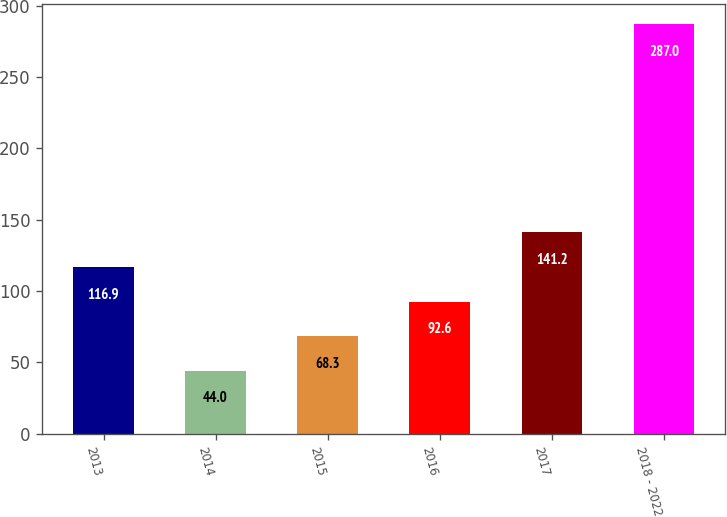<chart> <loc_0><loc_0><loc_500><loc_500><bar_chart><fcel>2013<fcel>2014<fcel>2015<fcel>2016<fcel>2017<fcel>2018 - 2022<nl><fcel>116.9<fcel>44<fcel>68.3<fcel>92.6<fcel>141.2<fcel>287<nl></chart> 